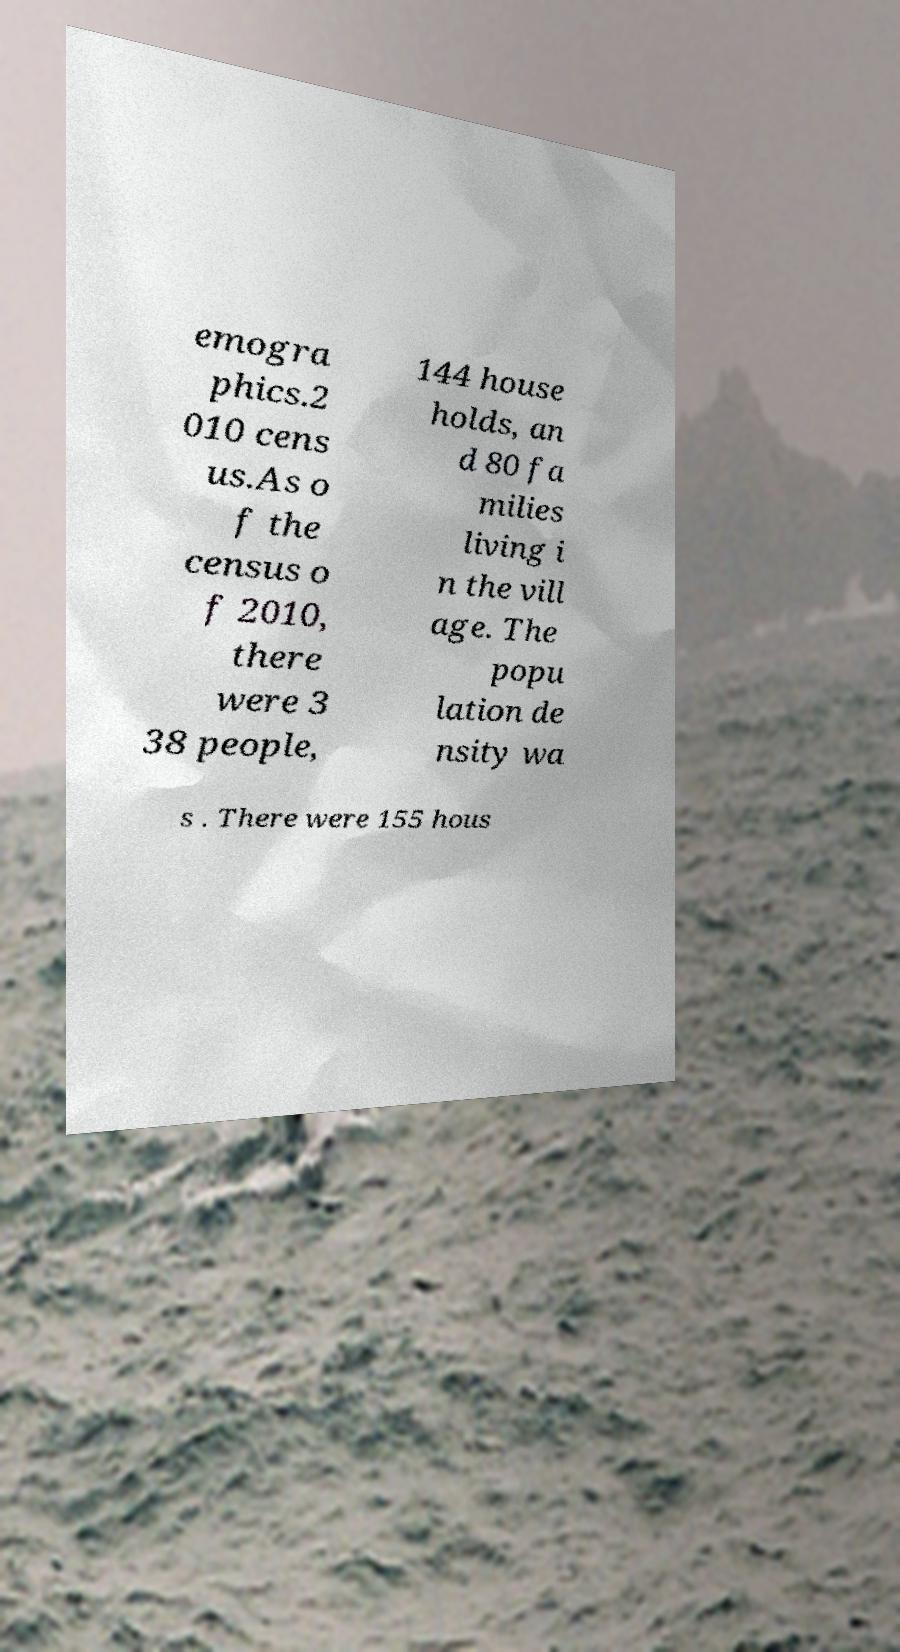Can you accurately transcribe the text from the provided image for me? emogra phics.2 010 cens us.As o f the census o f 2010, there were 3 38 people, 144 house holds, an d 80 fa milies living i n the vill age. The popu lation de nsity wa s . There were 155 hous 